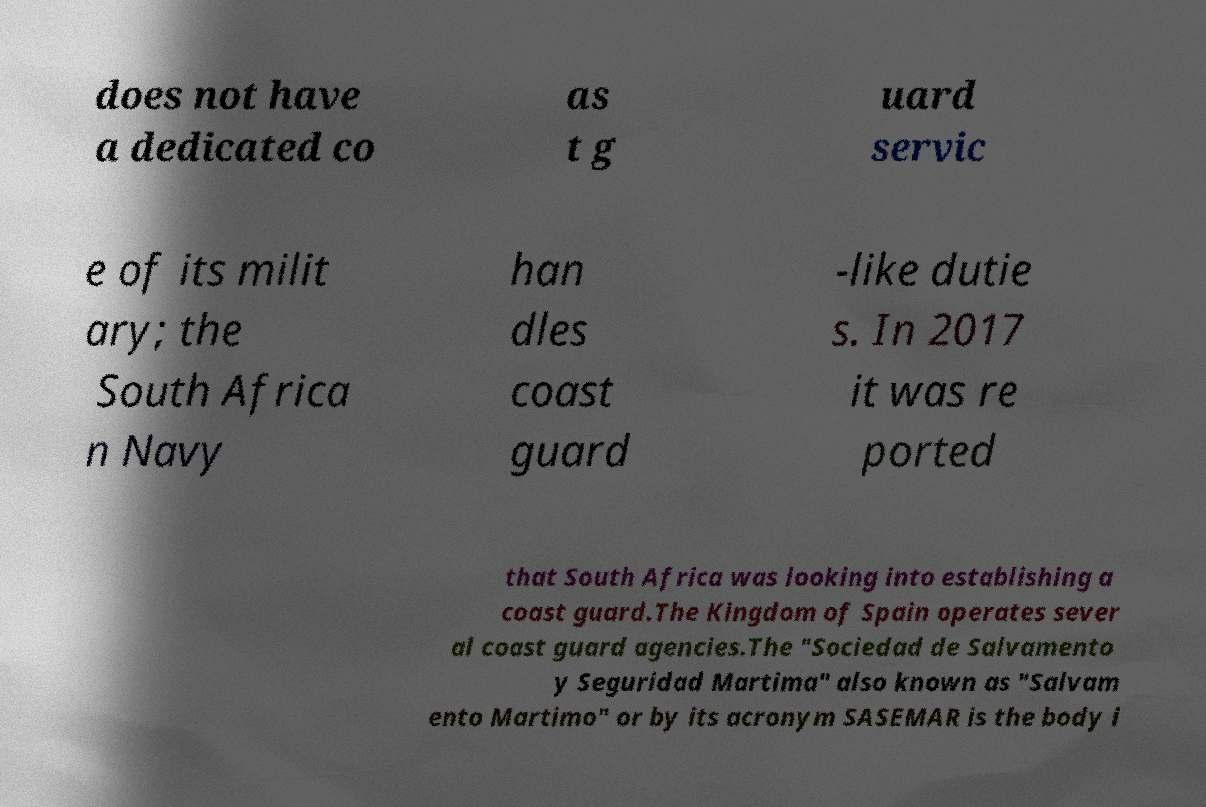For documentation purposes, I need the text within this image transcribed. Could you provide that? does not have a dedicated co as t g uard servic e of its milit ary; the South Africa n Navy han dles coast guard -like dutie s. In 2017 it was re ported that South Africa was looking into establishing a coast guard.The Kingdom of Spain operates sever al coast guard agencies.The "Sociedad de Salvamento y Seguridad Martima" also known as "Salvam ento Martimo" or by its acronym SASEMAR is the body i 